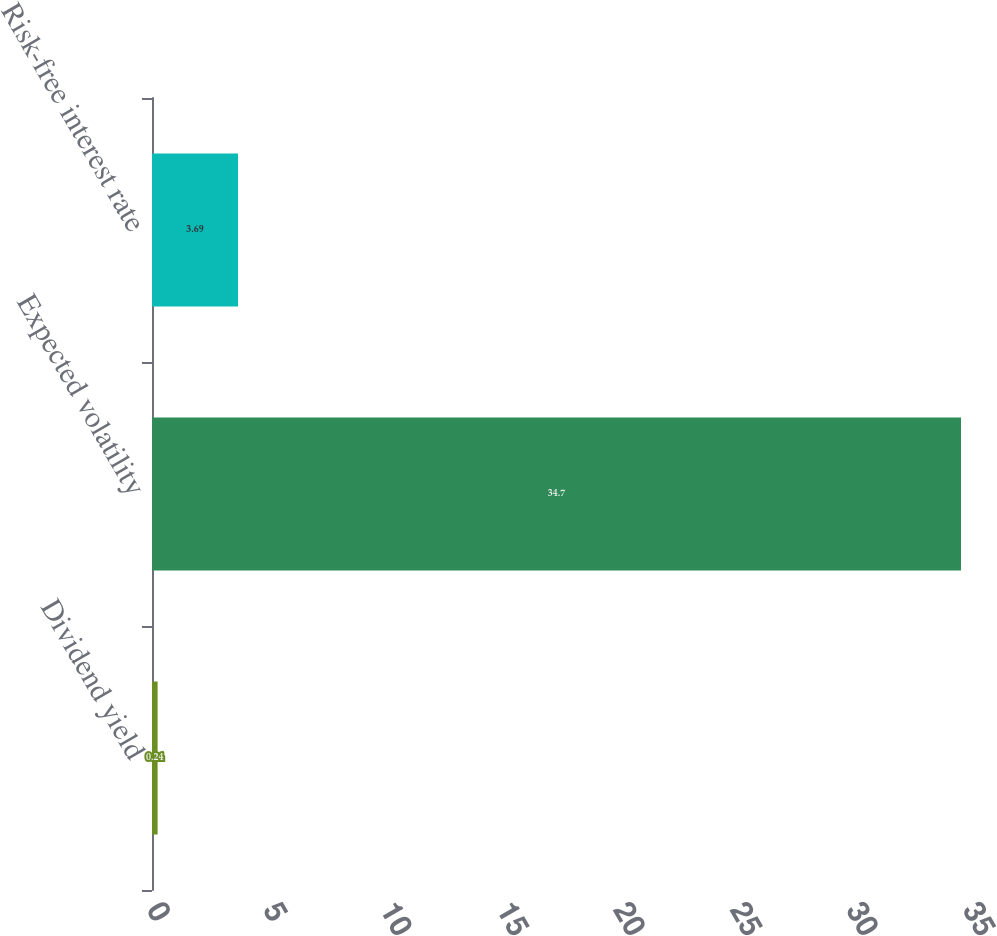Convert chart. <chart><loc_0><loc_0><loc_500><loc_500><bar_chart><fcel>Dividend yield<fcel>Expected volatility<fcel>Risk-free interest rate<nl><fcel>0.24<fcel>34.7<fcel>3.69<nl></chart> 